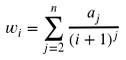<formula> <loc_0><loc_0><loc_500><loc_500>w _ { i } = \sum _ { j = 2 } ^ { n } \frac { a _ { j } } { ( i + 1 ) ^ { j } }</formula> 